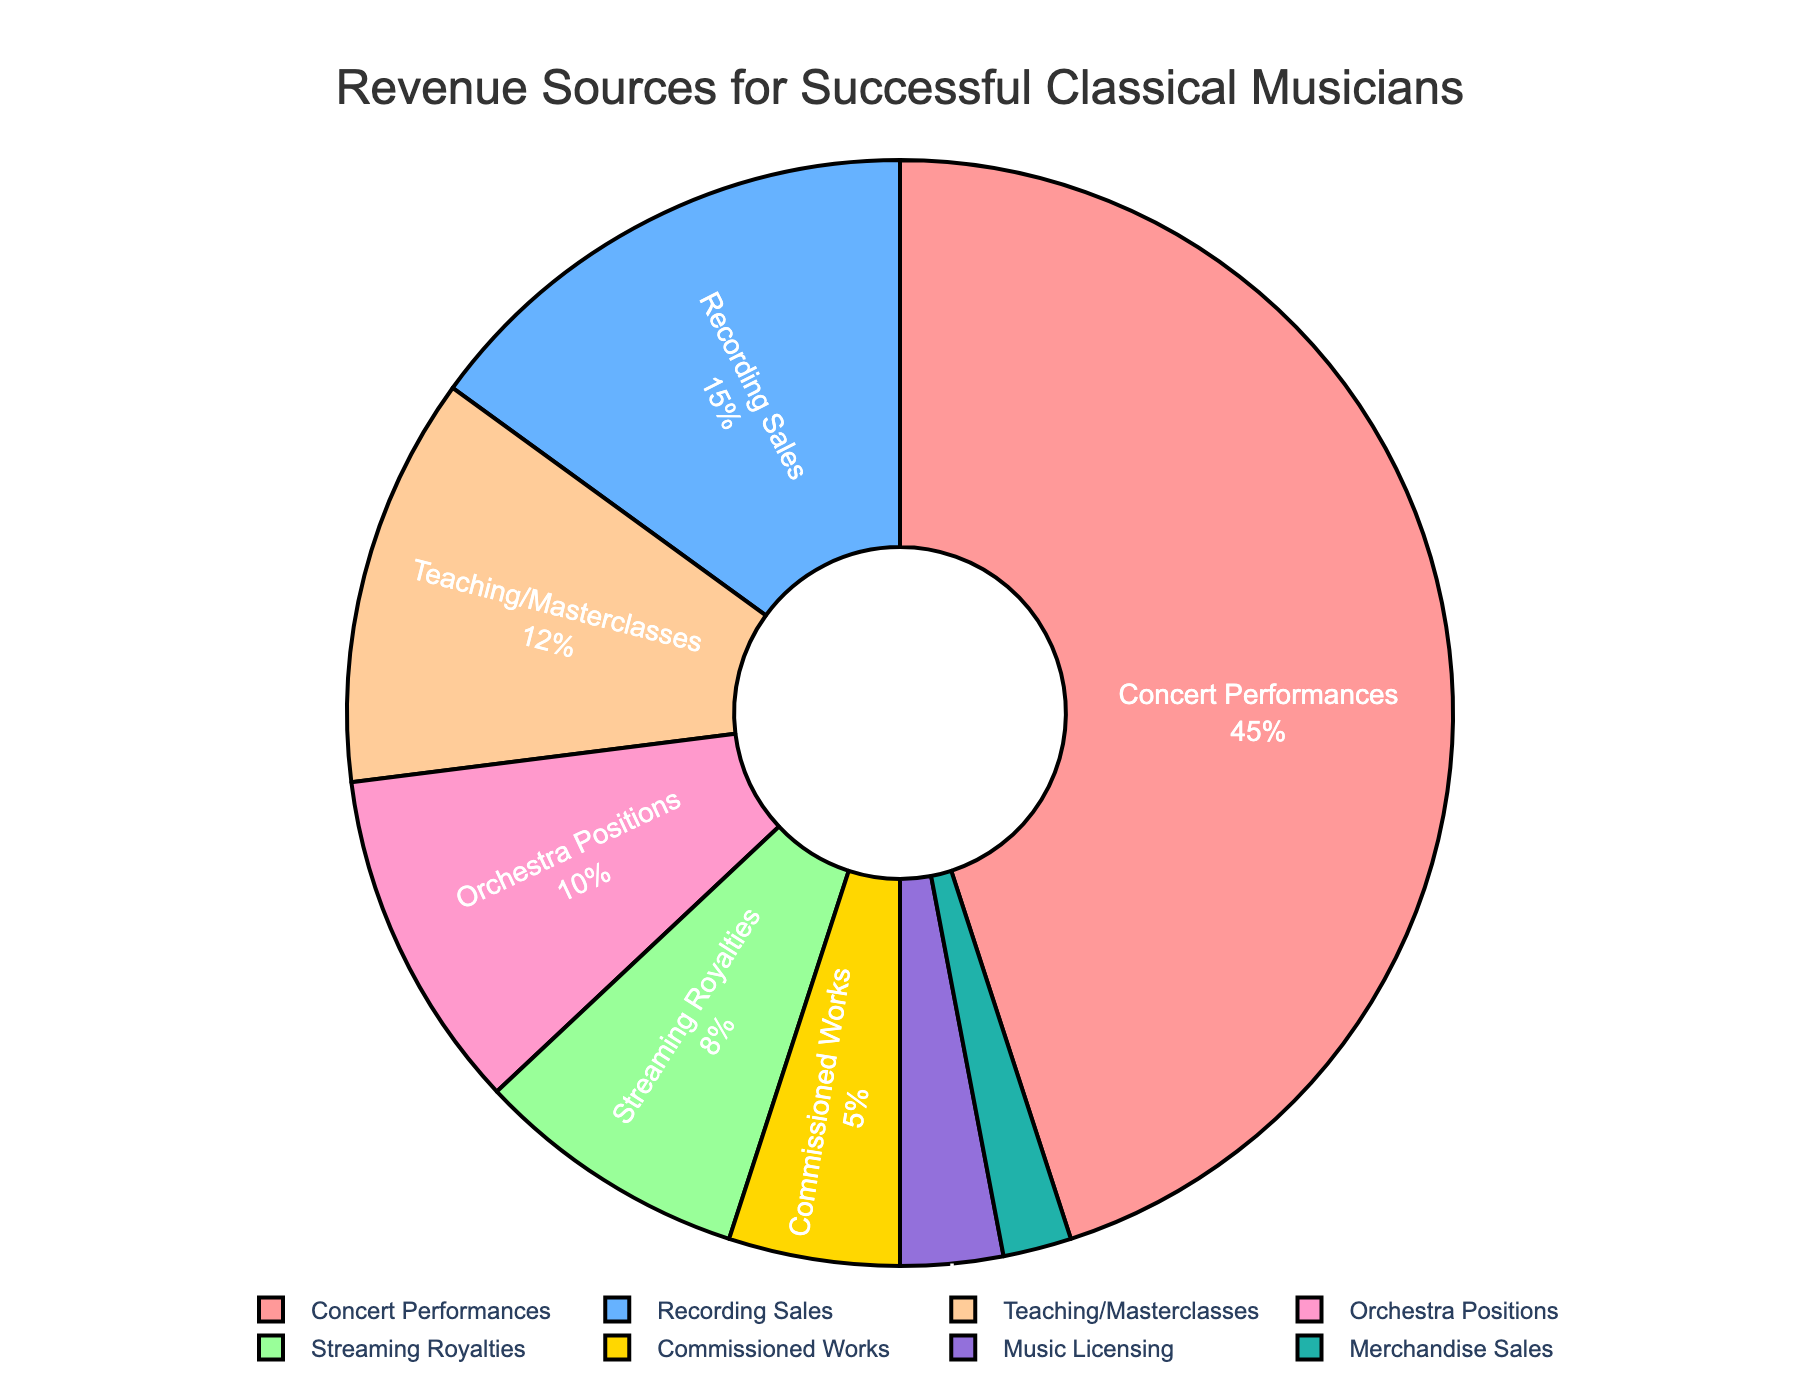What is the largest revenue source for successful classical musicians? The largest section in the pie chart represents 'Concert Performances', which occupies the largest area. Thus, the largest revenue source is 'Concert Performances'.
Answer: Concert Performances How much do 'Recording Sales' and 'Streaming Royalties' contribute together to the total revenue? Summing the percentages of 'Recording Sales' (15%) and 'Streaming Royalties' (8%) results in 15% + 8% = 23%.
Answer: 23% Which revenue source contributes more, 'Teaching/Masterclasses' or 'Orchestra Positions'? Comparing both sections in the pie chart, 'Teaching/Masterclasses' has 12% while 'Orchestra Positions' has 10%. Therefore, 'Teaching/Masterclasses' contributes more.
Answer: Teaching/Masterclasses What is the combined contribution of 'Commissioned Works', 'Music Licensing', and 'Merchandise Sales'? Summing the percentages of 'Commissioned Works' (5%), 'Music Licensing' (3%), and 'Merchandise Sales' (2%) results in 5% + 3% + 2% = 10%.
Answer: 10% Which revenue source is represented by the smallest section in the pie chart? The smallest section in the pie chart, in terms of area, represents 'Merchandise Sales'.
Answer: Merchandise Sales How much larger in percentage terms is 'Concert Performances' compared to 'Orchestra Positions'? The percentage for 'Concert Performances' is 45% and for 'Orchestra Positions' is 10%. Subtracting the latter from the former gives 45% - 10% = 35%.
Answer: 35% If the total revenue was $1,000,000, how much would come from 'Teaching/Masterclasses'? With 12% of the total revenue coming from 'Teaching/Masterclasses', multiplying $1,000,000 by 12% results in $1,000,000 * 0.12 = $120,000.
Answer: $120,000 By observing the pie chart, what color represents 'Music Licensing'? The section for 'Music Licensing' is visually represented by the dark yellow color in the pie chart.
Answer: Dark Yellow What is the ratio of 'Concert Performances' revenue to 'Recording Sales' revenue? The percentages for 'Concert Performances' and 'Recording Sales' are 45% and 15%, respectively. The ratio is 45:15, which simplifies to 3:1.
Answer: 3:1 Which revenue sources combined make up less than 10% of the total revenue? The revenue sources with percentages less than 10% are 'Streaming Royalties' (8%), 'Commissioned Works' (5%), 'Music Licensing' (3%), and 'Merchandise Sales' (2%). Adding them: 8% + 5% + 3% + 2% = 18%, but only 'Music Licensing' and 'Merchandise Sales' together make less than 10%.
Answer: Music Licensing and Merchandise Sales 